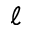Convert formula to latex. <formula><loc_0><loc_0><loc_500><loc_500>\ell</formula> 